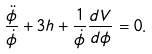Convert formula to latex. <formula><loc_0><loc_0><loc_500><loc_500>\frac { \ddot { \phi } } { \dot { \phi } } + 3 h + \frac { 1 } { \dot { \phi } } \frac { d V } { d \phi } = 0 .</formula> 